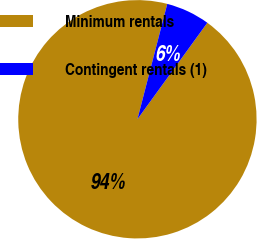Convert chart to OTSL. <chart><loc_0><loc_0><loc_500><loc_500><pie_chart><fcel>Minimum rentals<fcel>Contingent rentals (1)<nl><fcel>94.05%<fcel>5.95%<nl></chart> 